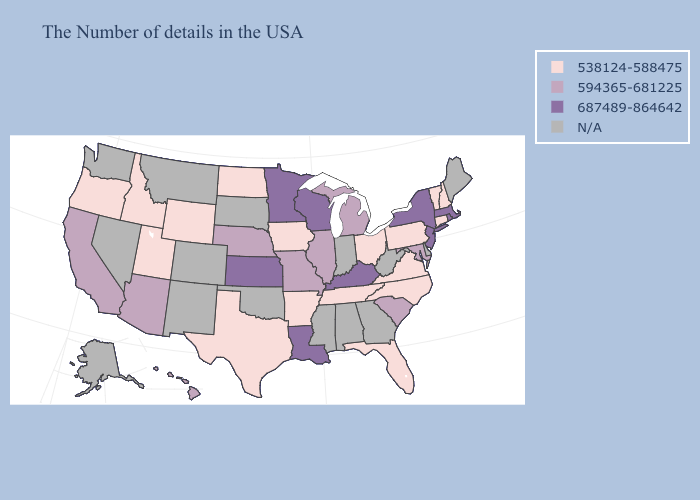Does Missouri have the highest value in the MidWest?
Keep it brief. No. What is the highest value in the South ?
Answer briefly. 687489-864642. What is the value of New Jersey?
Give a very brief answer. 687489-864642. Name the states that have a value in the range 538124-588475?
Keep it brief. New Hampshire, Vermont, Connecticut, Pennsylvania, Virginia, North Carolina, Ohio, Florida, Tennessee, Arkansas, Iowa, Texas, North Dakota, Wyoming, Utah, Idaho, Oregon. Name the states that have a value in the range N/A?
Answer briefly. Maine, Delaware, West Virginia, Georgia, Indiana, Alabama, Mississippi, Oklahoma, South Dakota, Colorado, New Mexico, Montana, Nevada, Washington, Alaska. What is the value of Georgia?
Short answer required. N/A. Does Hawaii have the lowest value in the West?
Write a very short answer. No. Among the states that border Georgia , which have the highest value?
Short answer required. South Carolina. Name the states that have a value in the range 538124-588475?
Short answer required. New Hampshire, Vermont, Connecticut, Pennsylvania, Virginia, North Carolina, Ohio, Florida, Tennessee, Arkansas, Iowa, Texas, North Dakota, Wyoming, Utah, Idaho, Oregon. What is the lowest value in the West?
Concise answer only. 538124-588475. What is the value of West Virginia?
Concise answer only. N/A. What is the value of Minnesota?
Quick response, please. 687489-864642. Name the states that have a value in the range 687489-864642?
Answer briefly. Massachusetts, Rhode Island, New York, New Jersey, Kentucky, Wisconsin, Louisiana, Minnesota, Kansas. Name the states that have a value in the range 594365-681225?
Keep it brief. Maryland, South Carolina, Michigan, Illinois, Missouri, Nebraska, Arizona, California, Hawaii. What is the highest value in the MidWest ?
Keep it brief. 687489-864642. 